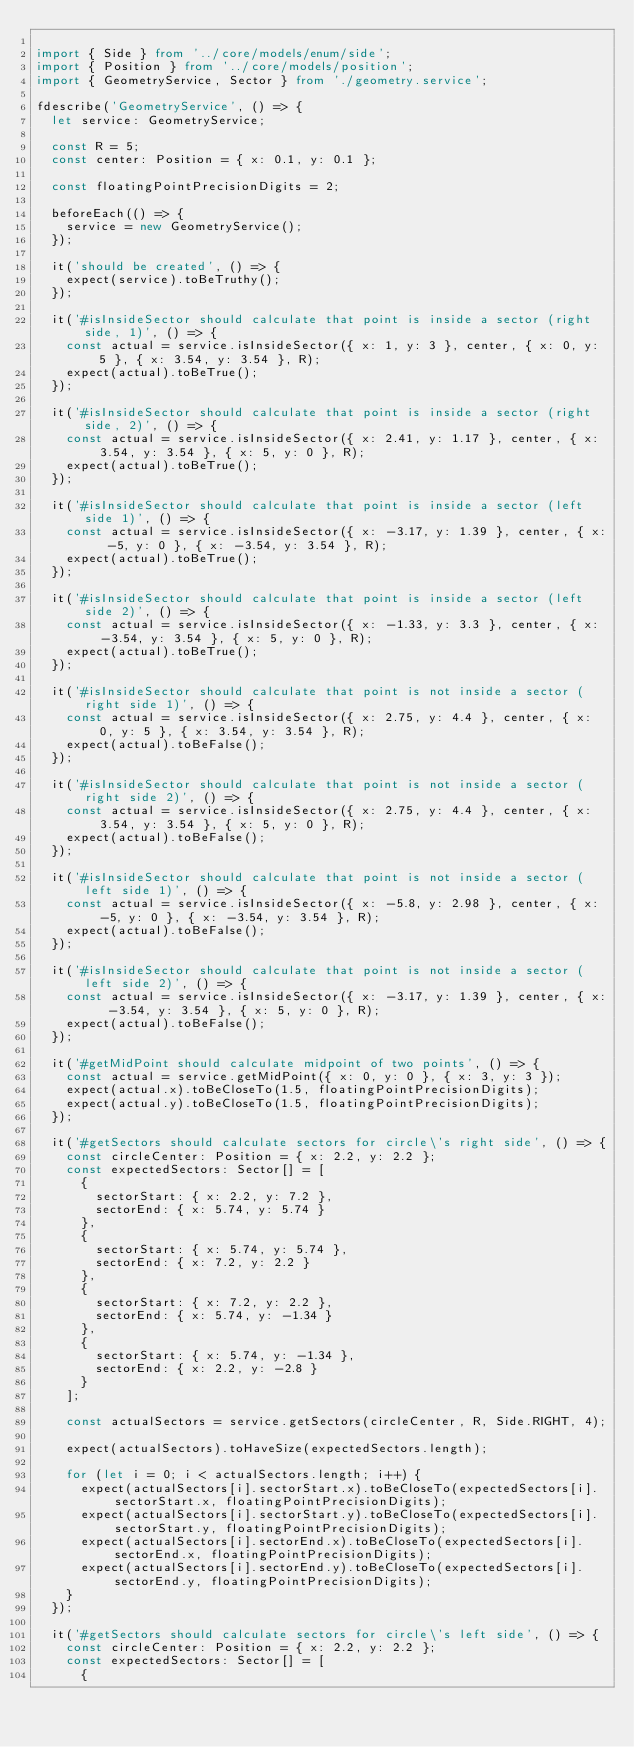<code> <loc_0><loc_0><loc_500><loc_500><_TypeScript_>
import { Side } from '../core/models/enum/side';
import { Position } from '../core/models/position';
import { GeometryService, Sector } from './geometry.service';

fdescribe('GeometryService', () => {
  let service: GeometryService;

  const R = 5;
  const center: Position = { x: 0.1, y: 0.1 };

  const floatingPointPrecisionDigits = 2;

  beforeEach(() => {
    service = new GeometryService();
  });

  it('should be created', () => {
    expect(service).toBeTruthy();
  });

  it('#isInsideSector should calculate that point is inside a sector (right side, 1)', () => {
    const actual = service.isInsideSector({ x: 1, y: 3 }, center, { x: 0, y: 5 }, { x: 3.54, y: 3.54 }, R);
    expect(actual).toBeTrue();
  });

  it('#isInsideSector should calculate that point is inside a sector (right side, 2)', () => {
    const actual = service.isInsideSector({ x: 2.41, y: 1.17 }, center, { x: 3.54, y: 3.54 }, { x: 5, y: 0 }, R);
    expect(actual).toBeTrue();
  });

  it('#isInsideSector should calculate that point is inside a sector (left side 1)', () => {
    const actual = service.isInsideSector({ x: -3.17, y: 1.39 }, center, { x: -5, y: 0 }, { x: -3.54, y: 3.54 }, R);
    expect(actual).toBeTrue();
  });

  it('#isInsideSector should calculate that point is inside a sector (left side 2)', () => {
    const actual = service.isInsideSector({ x: -1.33, y: 3.3 }, center, { x: -3.54, y: 3.54 }, { x: 5, y: 0 }, R);
    expect(actual).toBeTrue();
  });

  it('#isInsideSector should calculate that point is not inside a sector (right side 1)', () => {
    const actual = service.isInsideSector({ x: 2.75, y: 4.4 }, center, { x: 0, y: 5 }, { x: 3.54, y: 3.54 }, R);
    expect(actual).toBeFalse();
  });

  it('#isInsideSector should calculate that point is not inside a sector (right side 2)', () => {
    const actual = service.isInsideSector({ x: 2.75, y: 4.4 }, center, { x: 3.54, y: 3.54 }, { x: 5, y: 0 }, R);
    expect(actual).toBeFalse();
  });

  it('#isInsideSector should calculate that point is not inside a sector (left side 1)', () => {
    const actual = service.isInsideSector({ x: -5.8, y: 2.98 }, center, { x: -5, y: 0 }, { x: -3.54, y: 3.54 }, R);
    expect(actual).toBeFalse();
  });

  it('#isInsideSector should calculate that point is not inside a sector (left side 2)', () => {
    const actual = service.isInsideSector({ x: -3.17, y: 1.39 }, center, { x: -3.54, y: 3.54 }, { x: 5, y: 0 }, R);
    expect(actual).toBeFalse();
  });

  it('#getMidPoint should calculate midpoint of two points', () => {
    const actual = service.getMidPoint({ x: 0, y: 0 }, { x: 3, y: 3 });
    expect(actual.x).toBeCloseTo(1.5, floatingPointPrecisionDigits);
    expect(actual.y).toBeCloseTo(1.5, floatingPointPrecisionDigits);
  });

  it('#getSectors should calculate sectors for circle\'s right side', () => {
    const circleCenter: Position = { x: 2.2, y: 2.2 };
    const expectedSectors: Sector[] = [
      {
        sectorStart: { x: 2.2, y: 7.2 },
        sectorEnd: { x: 5.74, y: 5.74 }
      },
      {
        sectorStart: { x: 5.74, y: 5.74 },
        sectorEnd: { x: 7.2, y: 2.2 }
      },
      {
        sectorStart: { x: 7.2, y: 2.2 },
        sectorEnd: { x: 5.74, y: -1.34 }
      },
      {
        sectorStart: { x: 5.74, y: -1.34 },
        sectorEnd: { x: 2.2, y: -2.8 }
      }
    ];

    const actualSectors = service.getSectors(circleCenter, R, Side.RIGHT, 4);

    expect(actualSectors).toHaveSize(expectedSectors.length);

    for (let i = 0; i < actualSectors.length; i++) {
      expect(actualSectors[i].sectorStart.x).toBeCloseTo(expectedSectors[i].sectorStart.x, floatingPointPrecisionDigits);
      expect(actualSectors[i].sectorStart.y).toBeCloseTo(expectedSectors[i].sectorStart.y, floatingPointPrecisionDigits);
      expect(actualSectors[i].sectorEnd.x).toBeCloseTo(expectedSectors[i].sectorEnd.x, floatingPointPrecisionDigits);
      expect(actualSectors[i].sectorEnd.y).toBeCloseTo(expectedSectors[i].sectorEnd.y, floatingPointPrecisionDigits);
    }
  });

  it('#getSectors should calculate sectors for circle\'s left side', () => {
    const circleCenter: Position = { x: 2.2, y: 2.2 };
    const expectedSectors: Sector[] = [
      {</code> 